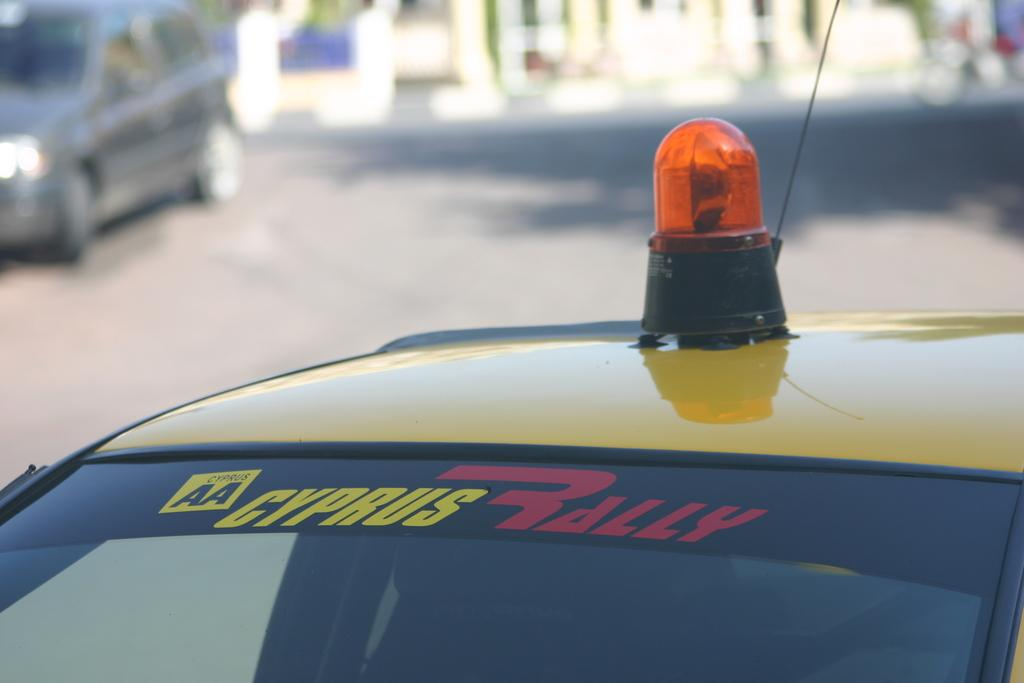<image>
Relay a brief, clear account of the picture shown. The top of a car with Cyprus Bally written on the windshield. 